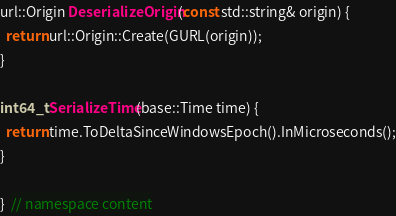Convert code to text. <code><loc_0><loc_0><loc_500><loc_500><_C++_>
url::Origin DeserializeOrigin(const std::string& origin) {
  return url::Origin::Create(GURL(origin));
}

int64_t SerializeTime(base::Time time) {
  return time.ToDeltaSinceWindowsEpoch().InMicroseconds();
}

}  // namespace content
</code> 